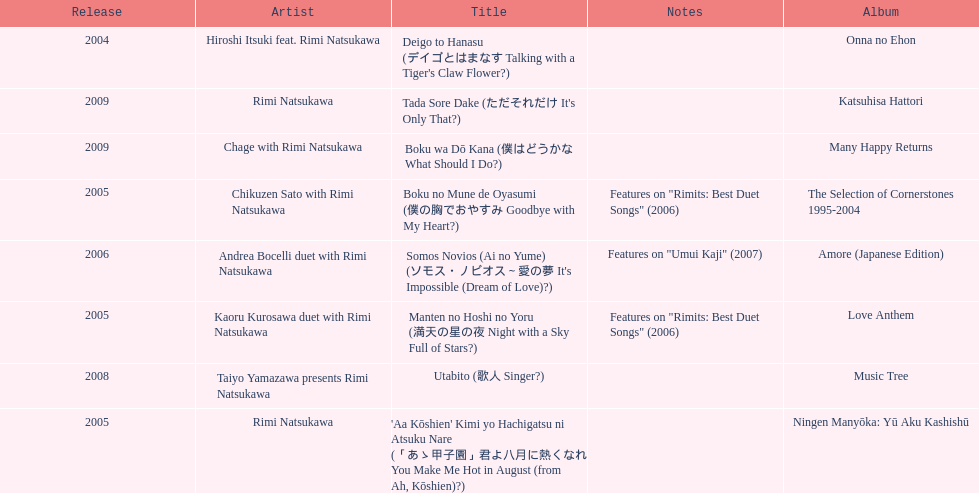How many other appearance did this artist make in 2005? 3. 